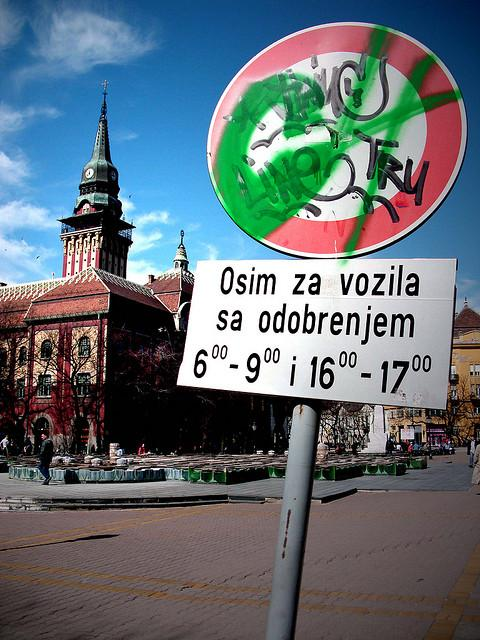What are the green markings an example of? Please explain your reasoning. graffiti. The markings are graffiti. 